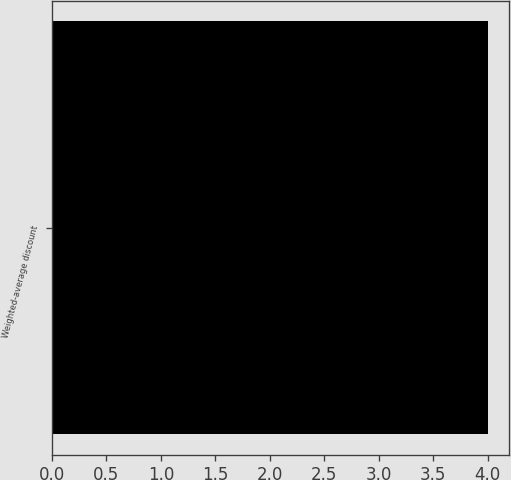Convert chart to OTSL. <chart><loc_0><loc_0><loc_500><loc_500><bar_chart><fcel>Weighted-average discount<nl><fcel>4<nl></chart> 